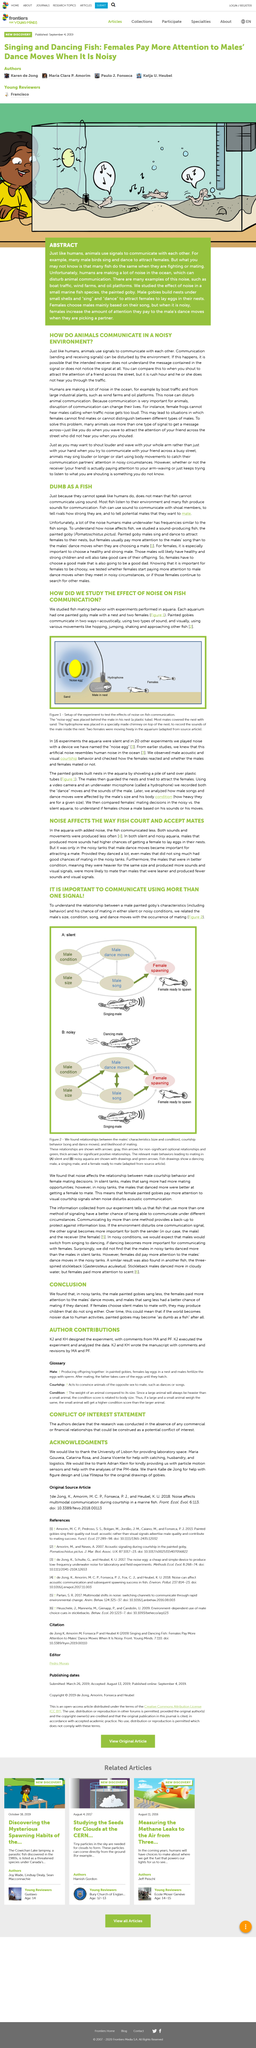Outline some significant characteristics in this image. Communicating by more than one method provides a backup to protect against information loss and ensures that the information is not lost in case of failure of any single communication method. The relationship between male courtship behavior and female mating decisions is affected by noise. The scientific name for the three-spined stickleback is Gasterosteus aculeatus. Animals communicate in a noisy environment by employing various strategies to ensure that their messages are received by their communication partners, such as singing louder or longer or using body movement to catch their attention. The experiments in the aquaria were silent in 16 of them. 